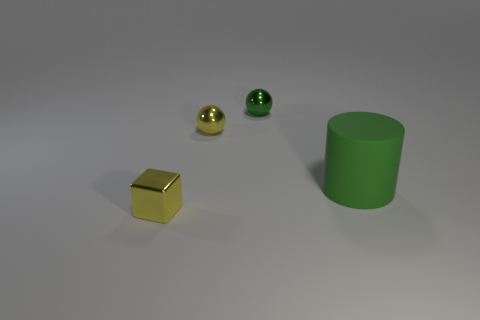Add 2 red matte spheres. How many objects exist? 6 Subtract all cubes. How many objects are left? 3 Subtract all tiny green metal cylinders. Subtract all rubber cylinders. How many objects are left? 3 Add 1 big green objects. How many big green objects are left? 2 Add 2 tiny metallic balls. How many tiny metallic balls exist? 4 Subtract 1 yellow balls. How many objects are left? 3 